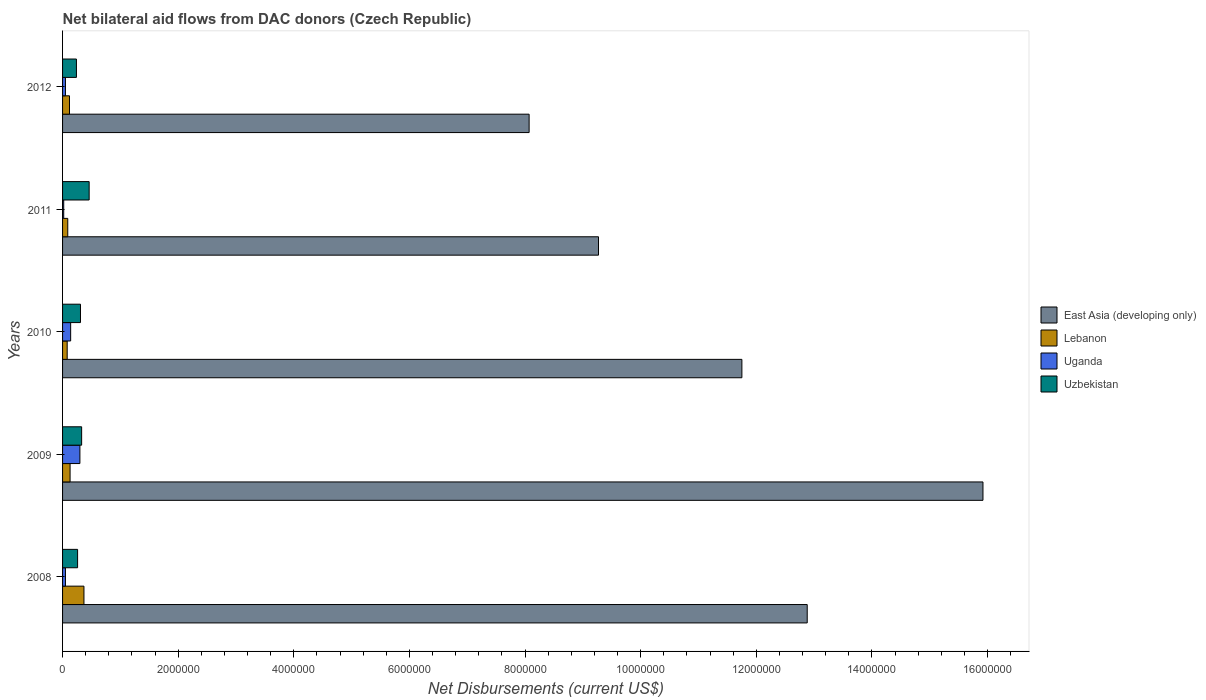Are the number of bars per tick equal to the number of legend labels?
Offer a terse response. Yes. How many bars are there on the 2nd tick from the top?
Your answer should be compact. 4. How many bars are there on the 3rd tick from the bottom?
Give a very brief answer. 4. In how many cases, is the number of bars for a given year not equal to the number of legend labels?
Your answer should be compact. 0. What is the net bilateral aid flows in Lebanon in 2009?
Make the answer very short. 1.30e+05. Across all years, what is the maximum net bilateral aid flows in Uganda?
Offer a very short reply. 3.00e+05. Across all years, what is the minimum net bilateral aid flows in Uzbekistan?
Provide a short and direct response. 2.40e+05. What is the total net bilateral aid flows in Lebanon in the graph?
Offer a very short reply. 7.90e+05. What is the difference between the net bilateral aid flows in Uzbekistan in 2008 and that in 2011?
Give a very brief answer. -2.00e+05. What is the difference between the net bilateral aid flows in Uzbekistan in 2010 and the net bilateral aid flows in East Asia (developing only) in 2012?
Your response must be concise. -7.76e+06. What is the average net bilateral aid flows in Uganda per year?
Provide a short and direct response. 1.12e+05. In the year 2010, what is the difference between the net bilateral aid flows in Uzbekistan and net bilateral aid flows in Uganda?
Keep it short and to the point. 1.70e+05. What is the ratio of the net bilateral aid flows in Lebanon in 2011 to that in 2012?
Keep it short and to the point. 0.75. Is the net bilateral aid flows in East Asia (developing only) in 2009 less than that in 2011?
Your response must be concise. No. What is the difference between the highest and the lowest net bilateral aid flows in Lebanon?
Provide a short and direct response. 2.90e+05. In how many years, is the net bilateral aid flows in Lebanon greater than the average net bilateral aid flows in Lebanon taken over all years?
Your answer should be compact. 1. Is the sum of the net bilateral aid flows in East Asia (developing only) in 2010 and 2011 greater than the maximum net bilateral aid flows in Lebanon across all years?
Your answer should be compact. Yes. What does the 1st bar from the top in 2010 represents?
Your response must be concise. Uzbekistan. What does the 4th bar from the bottom in 2012 represents?
Keep it short and to the point. Uzbekistan. Is it the case that in every year, the sum of the net bilateral aid flows in Uzbekistan and net bilateral aid flows in East Asia (developing only) is greater than the net bilateral aid flows in Uganda?
Offer a very short reply. Yes. How many bars are there?
Your response must be concise. 20. What is the title of the graph?
Give a very brief answer. Net bilateral aid flows from DAC donors (Czech Republic). Does "Chad" appear as one of the legend labels in the graph?
Keep it short and to the point. No. What is the label or title of the X-axis?
Make the answer very short. Net Disbursements (current US$). What is the label or title of the Y-axis?
Give a very brief answer. Years. What is the Net Disbursements (current US$) in East Asia (developing only) in 2008?
Offer a terse response. 1.29e+07. What is the Net Disbursements (current US$) in Uzbekistan in 2008?
Give a very brief answer. 2.60e+05. What is the Net Disbursements (current US$) of East Asia (developing only) in 2009?
Keep it short and to the point. 1.59e+07. What is the Net Disbursements (current US$) of Lebanon in 2009?
Your response must be concise. 1.30e+05. What is the Net Disbursements (current US$) of Uzbekistan in 2009?
Your answer should be compact. 3.30e+05. What is the Net Disbursements (current US$) of East Asia (developing only) in 2010?
Make the answer very short. 1.18e+07. What is the Net Disbursements (current US$) of Lebanon in 2010?
Your response must be concise. 8.00e+04. What is the Net Disbursements (current US$) in Uganda in 2010?
Your answer should be very brief. 1.40e+05. What is the Net Disbursements (current US$) of Uzbekistan in 2010?
Provide a short and direct response. 3.10e+05. What is the Net Disbursements (current US$) of East Asia (developing only) in 2011?
Offer a terse response. 9.27e+06. What is the Net Disbursements (current US$) in Uganda in 2011?
Your answer should be compact. 2.00e+04. What is the Net Disbursements (current US$) of Uzbekistan in 2011?
Offer a very short reply. 4.60e+05. What is the Net Disbursements (current US$) of East Asia (developing only) in 2012?
Ensure brevity in your answer.  8.07e+06. What is the Net Disbursements (current US$) of Lebanon in 2012?
Ensure brevity in your answer.  1.20e+05. What is the Net Disbursements (current US$) of Uganda in 2012?
Provide a short and direct response. 5.00e+04. Across all years, what is the maximum Net Disbursements (current US$) of East Asia (developing only)?
Give a very brief answer. 1.59e+07. Across all years, what is the maximum Net Disbursements (current US$) of Lebanon?
Provide a succinct answer. 3.70e+05. Across all years, what is the maximum Net Disbursements (current US$) of Uzbekistan?
Your answer should be compact. 4.60e+05. Across all years, what is the minimum Net Disbursements (current US$) of East Asia (developing only)?
Provide a short and direct response. 8.07e+06. Across all years, what is the minimum Net Disbursements (current US$) of Uganda?
Make the answer very short. 2.00e+04. Across all years, what is the minimum Net Disbursements (current US$) of Uzbekistan?
Keep it short and to the point. 2.40e+05. What is the total Net Disbursements (current US$) of East Asia (developing only) in the graph?
Your response must be concise. 5.79e+07. What is the total Net Disbursements (current US$) of Lebanon in the graph?
Offer a very short reply. 7.90e+05. What is the total Net Disbursements (current US$) in Uganda in the graph?
Provide a short and direct response. 5.60e+05. What is the total Net Disbursements (current US$) of Uzbekistan in the graph?
Offer a very short reply. 1.60e+06. What is the difference between the Net Disbursements (current US$) of East Asia (developing only) in 2008 and that in 2009?
Provide a succinct answer. -3.04e+06. What is the difference between the Net Disbursements (current US$) of Uganda in 2008 and that in 2009?
Keep it short and to the point. -2.50e+05. What is the difference between the Net Disbursements (current US$) of East Asia (developing only) in 2008 and that in 2010?
Offer a very short reply. 1.13e+06. What is the difference between the Net Disbursements (current US$) in East Asia (developing only) in 2008 and that in 2011?
Offer a very short reply. 3.61e+06. What is the difference between the Net Disbursements (current US$) of East Asia (developing only) in 2008 and that in 2012?
Offer a terse response. 4.81e+06. What is the difference between the Net Disbursements (current US$) in Lebanon in 2008 and that in 2012?
Offer a terse response. 2.50e+05. What is the difference between the Net Disbursements (current US$) in Uzbekistan in 2008 and that in 2012?
Give a very brief answer. 2.00e+04. What is the difference between the Net Disbursements (current US$) of East Asia (developing only) in 2009 and that in 2010?
Your answer should be very brief. 4.17e+06. What is the difference between the Net Disbursements (current US$) of Lebanon in 2009 and that in 2010?
Offer a very short reply. 5.00e+04. What is the difference between the Net Disbursements (current US$) of Uganda in 2009 and that in 2010?
Provide a succinct answer. 1.60e+05. What is the difference between the Net Disbursements (current US$) in East Asia (developing only) in 2009 and that in 2011?
Your response must be concise. 6.65e+06. What is the difference between the Net Disbursements (current US$) of Uzbekistan in 2009 and that in 2011?
Keep it short and to the point. -1.30e+05. What is the difference between the Net Disbursements (current US$) of East Asia (developing only) in 2009 and that in 2012?
Ensure brevity in your answer.  7.85e+06. What is the difference between the Net Disbursements (current US$) in Uganda in 2009 and that in 2012?
Keep it short and to the point. 2.50e+05. What is the difference between the Net Disbursements (current US$) of East Asia (developing only) in 2010 and that in 2011?
Provide a succinct answer. 2.48e+06. What is the difference between the Net Disbursements (current US$) of Uganda in 2010 and that in 2011?
Your answer should be very brief. 1.20e+05. What is the difference between the Net Disbursements (current US$) of Uzbekistan in 2010 and that in 2011?
Make the answer very short. -1.50e+05. What is the difference between the Net Disbursements (current US$) of East Asia (developing only) in 2010 and that in 2012?
Make the answer very short. 3.68e+06. What is the difference between the Net Disbursements (current US$) of East Asia (developing only) in 2011 and that in 2012?
Provide a short and direct response. 1.20e+06. What is the difference between the Net Disbursements (current US$) of Lebanon in 2011 and that in 2012?
Provide a succinct answer. -3.00e+04. What is the difference between the Net Disbursements (current US$) of Uzbekistan in 2011 and that in 2012?
Keep it short and to the point. 2.20e+05. What is the difference between the Net Disbursements (current US$) in East Asia (developing only) in 2008 and the Net Disbursements (current US$) in Lebanon in 2009?
Your response must be concise. 1.28e+07. What is the difference between the Net Disbursements (current US$) in East Asia (developing only) in 2008 and the Net Disbursements (current US$) in Uganda in 2009?
Provide a succinct answer. 1.26e+07. What is the difference between the Net Disbursements (current US$) of East Asia (developing only) in 2008 and the Net Disbursements (current US$) of Uzbekistan in 2009?
Offer a very short reply. 1.26e+07. What is the difference between the Net Disbursements (current US$) of Lebanon in 2008 and the Net Disbursements (current US$) of Uganda in 2009?
Your response must be concise. 7.00e+04. What is the difference between the Net Disbursements (current US$) in Uganda in 2008 and the Net Disbursements (current US$) in Uzbekistan in 2009?
Make the answer very short. -2.80e+05. What is the difference between the Net Disbursements (current US$) in East Asia (developing only) in 2008 and the Net Disbursements (current US$) in Lebanon in 2010?
Make the answer very short. 1.28e+07. What is the difference between the Net Disbursements (current US$) in East Asia (developing only) in 2008 and the Net Disbursements (current US$) in Uganda in 2010?
Your answer should be compact. 1.27e+07. What is the difference between the Net Disbursements (current US$) of East Asia (developing only) in 2008 and the Net Disbursements (current US$) of Uzbekistan in 2010?
Give a very brief answer. 1.26e+07. What is the difference between the Net Disbursements (current US$) of Lebanon in 2008 and the Net Disbursements (current US$) of Uzbekistan in 2010?
Offer a very short reply. 6.00e+04. What is the difference between the Net Disbursements (current US$) in Uganda in 2008 and the Net Disbursements (current US$) in Uzbekistan in 2010?
Your answer should be compact. -2.60e+05. What is the difference between the Net Disbursements (current US$) of East Asia (developing only) in 2008 and the Net Disbursements (current US$) of Lebanon in 2011?
Provide a succinct answer. 1.28e+07. What is the difference between the Net Disbursements (current US$) of East Asia (developing only) in 2008 and the Net Disbursements (current US$) of Uganda in 2011?
Offer a terse response. 1.29e+07. What is the difference between the Net Disbursements (current US$) in East Asia (developing only) in 2008 and the Net Disbursements (current US$) in Uzbekistan in 2011?
Make the answer very short. 1.24e+07. What is the difference between the Net Disbursements (current US$) of Lebanon in 2008 and the Net Disbursements (current US$) of Uzbekistan in 2011?
Your answer should be very brief. -9.00e+04. What is the difference between the Net Disbursements (current US$) of Uganda in 2008 and the Net Disbursements (current US$) of Uzbekistan in 2011?
Make the answer very short. -4.10e+05. What is the difference between the Net Disbursements (current US$) of East Asia (developing only) in 2008 and the Net Disbursements (current US$) of Lebanon in 2012?
Make the answer very short. 1.28e+07. What is the difference between the Net Disbursements (current US$) in East Asia (developing only) in 2008 and the Net Disbursements (current US$) in Uganda in 2012?
Your answer should be compact. 1.28e+07. What is the difference between the Net Disbursements (current US$) in East Asia (developing only) in 2008 and the Net Disbursements (current US$) in Uzbekistan in 2012?
Offer a terse response. 1.26e+07. What is the difference between the Net Disbursements (current US$) in Lebanon in 2008 and the Net Disbursements (current US$) in Uganda in 2012?
Your answer should be very brief. 3.20e+05. What is the difference between the Net Disbursements (current US$) of Uganda in 2008 and the Net Disbursements (current US$) of Uzbekistan in 2012?
Give a very brief answer. -1.90e+05. What is the difference between the Net Disbursements (current US$) in East Asia (developing only) in 2009 and the Net Disbursements (current US$) in Lebanon in 2010?
Your response must be concise. 1.58e+07. What is the difference between the Net Disbursements (current US$) in East Asia (developing only) in 2009 and the Net Disbursements (current US$) in Uganda in 2010?
Make the answer very short. 1.58e+07. What is the difference between the Net Disbursements (current US$) of East Asia (developing only) in 2009 and the Net Disbursements (current US$) of Uzbekistan in 2010?
Offer a very short reply. 1.56e+07. What is the difference between the Net Disbursements (current US$) in Lebanon in 2009 and the Net Disbursements (current US$) in Uganda in 2010?
Your response must be concise. -10000. What is the difference between the Net Disbursements (current US$) of Uganda in 2009 and the Net Disbursements (current US$) of Uzbekistan in 2010?
Your answer should be very brief. -10000. What is the difference between the Net Disbursements (current US$) of East Asia (developing only) in 2009 and the Net Disbursements (current US$) of Lebanon in 2011?
Your answer should be very brief. 1.58e+07. What is the difference between the Net Disbursements (current US$) of East Asia (developing only) in 2009 and the Net Disbursements (current US$) of Uganda in 2011?
Offer a terse response. 1.59e+07. What is the difference between the Net Disbursements (current US$) in East Asia (developing only) in 2009 and the Net Disbursements (current US$) in Uzbekistan in 2011?
Make the answer very short. 1.55e+07. What is the difference between the Net Disbursements (current US$) in Lebanon in 2009 and the Net Disbursements (current US$) in Uzbekistan in 2011?
Provide a short and direct response. -3.30e+05. What is the difference between the Net Disbursements (current US$) of Uganda in 2009 and the Net Disbursements (current US$) of Uzbekistan in 2011?
Your response must be concise. -1.60e+05. What is the difference between the Net Disbursements (current US$) of East Asia (developing only) in 2009 and the Net Disbursements (current US$) of Lebanon in 2012?
Your response must be concise. 1.58e+07. What is the difference between the Net Disbursements (current US$) in East Asia (developing only) in 2009 and the Net Disbursements (current US$) in Uganda in 2012?
Your answer should be compact. 1.59e+07. What is the difference between the Net Disbursements (current US$) in East Asia (developing only) in 2009 and the Net Disbursements (current US$) in Uzbekistan in 2012?
Your answer should be compact. 1.57e+07. What is the difference between the Net Disbursements (current US$) in East Asia (developing only) in 2010 and the Net Disbursements (current US$) in Lebanon in 2011?
Ensure brevity in your answer.  1.17e+07. What is the difference between the Net Disbursements (current US$) in East Asia (developing only) in 2010 and the Net Disbursements (current US$) in Uganda in 2011?
Your response must be concise. 1.17e+07. What is the difference between the Net Disbursements (current US$) in East Asia (developing only) in 2010 and the Net Disbursements (current US$) in Uzbekistan in 2011?
Your answer should be compact. 1.13e+07. What is the difference between the Net Disbursements (current US$) of Lebanon in 2010 and the Net Disbursements (current US$) of Uzbekistan in 2011?
Ensure brevity in your answer.  -3.80e+05. What is the difference between the Net Disbursements (current US$) in Uganda in 2010 and the Net Disbursements (current US$) in Uzbekistan in 2011?
Provide a short and direct response. -3.20e+05. What is the difference between the Net Disbursements (current US$) of East Asia (developing only) in 2010 and the Net Disbursements (current US$) of Lebanon in 2012?
Your answer should be compact. 1.16e+07. What is the difference between the Net Disbursements (current US$) in East Asia (developing only) in 2010 and the Net Disbursements (current US$) in Uganda in 2012?
Give a very brief answer. 1.17e+07. What is the difference between the Net Disbursements (current US$) of East Asia (developing only) in 2010 and the Net Disbursements (current US$) of Uzbekistan in 2012?
Keep it short and to the point. 1.15e+07. What is the difference between the Net Disbursements (current US$) in Lebanon in 2010 and the Net Disbursements (current US$) in Uganda in 2012?
Your response must be concise. 3.00e+04. What is the difference between the Net Disbursements (current US$) in Lebanon in 2010 and the Net Disbursements (current US$) in Uzbekistan in 2012?
Provide a short and direct response. -1.60e+05. What is the difference between the Net Disbursements (current US$) in Uganda in 2010 and the Net Disbursements (current US$) in Uzbekistan in 2012?
Your answer should be compact. -1.00e+05. What is the difference between the Net Disbursements (current US$) in East Asia (developing only) in 2011 and the Net Disbursements (current US$) in Lebanon in 2012?
Your answer should be compact. 9.15e+06. What is the difference between the Net Disbursements (current US$) of East Asia (developing only) in 2011 and the Net Disbursements (current US$) of Uganda in 2012?
Give a very brief answer. 9.22e+06. What is the difference between the Net Disbursements (current US$) of East Asia (developing only) in 2011 and the Net Disbursements (current US$) of Uzbekistan in 2012?
Give a very brief answer. 9.03e+06. What is the difference between the Net Disbursements (current US$) in Lebanon in 2011 and the Net Disbursements (current US$) in Uganda in 2012?
Your answer should be very brief. 4.00e+04. What is the difference between the Net Disbursements (current US$) in Lebanon in 2011 and the Net Disbursements (current US$) in Uzbekistan in 2012?
Your answer should be very brief. -1.50e+05. What is the difference between the Net Disbursements (current US$) of Uganda in 2011 and the Net Disbursements (current US$) of Uzbekistan in 2012?
Ensure brevity in your answer.  -2.20e+05. What is the average Net Disbursements (current US$) of East Asia (developing only) per year?
Your answer should be very brief. 1.16e+07. What is the average Net Disbursements (current US$) of Lebanon per year?
Provide a succinct answer. 1.58e+05. What is the average Net Disbursements (current US$) of Uganda per year?
Offer a terse response. 1.12e+05. In the year 2008, what is the difference between the Net Disbursements (current US$) in East Asia (developing only) and Net Disbursements (current US$) in Lebanon?
Your answer should be very brief. 1.25e+07. In the year 2008, what is the difference between the Net Disbursements (current US$) of East Asia (developing only) and Net Disbursements (current US$) of Uganda?
Provide a succinct answer. 1.28e+07. In the year 2008, what is the difference between the Net Disbursements (current US$) in East Asia (developing only) and Net Disbursements (current US$) in Uzbekistan?
Make the answer very short. 1.26e+07. In the year 2008, what is the difference between the Net Disbursements (current US$) in Lebanon and Net Disbursements (current US$) in Uzbekistan?
Ensure brevity in your answer.  1.10e+05. In the year 2009, what is the difference between the Net Disbursements (current US$) of East Asia (developing only) and Net Disbursements (current US$) of Lebanon?
Give a very brief answer. 1.58e+07. In the year 2009, what is the difference between the Net Disbursements (current US$) in East Asia (developing only) and Net Disbursements (current US$) in Uganda?
Make the answer very short. 1.56e+07. In the year 2009, what is the difference between the Net Disbursements (current US$) in East Asia (developing only) and Net Disbursements (current US$) in Uzbekistan?
Your answer should be compact. 1.56e+07. In the year 2009, what is the difference between the Net Disbursements (current US$) of Lebanon and Net Disbursements (current US$) of Uzbekistan?
Give a very brief answer. -2.00e+05. In the year 2009, what is the difference between the Net Disbursements (current US$) of Uganda and Net Disbursements (current US$) of Uzbekistan?
Offer a terse response. -3.00e+04. In the year 2010, what is the difference between the Net Disbursements (current US$) in East Asia (developing only) and Net Disbursements (current US$) in Lebanon?
Provide a succinct answer. 1.17e+07. In the year 2010, what is the difference between the Net Disbursements (current US$) of East Asia (developing only) and Net Disbursements (current US$) of Uganda?
Provide a short and direct response. 1.16e+07. In the year 2010, what is the difference between the Net Disbursements (current US$) in East Asia (developing only) and Net Disbursements (current US$) in Uzbekistan?
Ensure brevity in your answer.  1.14e+07. In the year 2011, what is the difference between the Net Disbursements (current US$) of East Asia (developing only) and Net Disbursements (current US$) of Lebanon?
Offer a terse response. 9.18e+06. In the year 2011, what is the difference between the Net Disbursements (current US$) of East Asia (developing only) and Net Disbursements (current US$) of Uganda?
Your response must be concise. 9.25e+06. In the year 2011, what is the difference between the Net Disbursements (current US$) in East Asia (developing only) and Net Disbursements (current US$) in Uzbekistan?
Keep it short and to the point. 8.81e+06. In the year 2011, what is the difference between the Net Disbursements (current US$) in Lebanon and Net Disbursements (current US$) in Uganda?
Keep it short and to the point. 7.00e+04. In the year 2011, what is the difference between the Net Disbursements (current US$) of Lebanon and Net Disbursements (current US$) of Uzbekistan?
Your answer should be compact. -3.70e+05. In the year 2011, what is the difference between the Net Disbursements (current US$) in Uganda and Net Disbursements (current US$) in Uzbekistan?
Your answer should be very brief. -4.40e+05. In the year 2012, what is the difference between the Net Disbursements (current US$) of East Asia (developing only) and Net Disbursements (current US$) of Lebanon?
Ensure brevity in your answer.  7.95e+06. In the year 2012, what is the difference between the Net Disbursements (current US$) in East Asia (developing only) and Net Disbursements (current US$) in Uganda?
Keep it short and to the point. 8.02e+06. In the year 2012, what is the difference between the Net Disbursements (current US$) of East Asia (developing only) and Net Disbursements (current US$) of Uzbekistan?
Your response must be concise. 7.83e+06. In the year 2012, what is the difference between the Net Disbursements (current US$) in Lebanon and Net Disbursements (current US$) in Uganda?
Offer a very short reply. 7.00e+04. In the year 2012, what is the difference between the Net Disbursements (current US$) in Lebanon and Net Disbursements (current US$) in Uzbekistan?
Your answer should be very brief. -1.20e+05. In the year 2012, what is the difference between the Net Disbursements (current US$) in Uganda and Net Disbursements (current US$) in Uzbekistan?
Your response must be concise. -1.90e+05. What is the ratio of the Net Disbursements (current US$) of East Asia (developing only) in 2008 to that in 2009?
Provide a succinct answer. 0.81. What is the ratio of the Net Disbursements (current US$) in Lebanon in 2008 to that in 2009?
Give a very brief answer. 2.85. What is the ratio of the Net Disbursements (current US$) in Uzbekistan in 2008 to that in 2009?
Provide a short and direct response. 0.79. What is the ratio of the Net Disbursements (current US$) of East Asia (developing only) in 2008 to that in 2010?
Make the answer very short. 1.1. What is the ratio of the Net Disbursements (current US$) of Lebanon in 2008 to that in 2010?
Your answer should be compact. 4.62. What is the ratio of the Net Disbursements (current US$) in Uganda in 2008 to that in 2010?
Ensure brevity in your answer.  0.36. What is the ratio of the Net Disbursements (current US$) of Uzbekistan in 2008 to that in 2010?
Provide a succinct answer. 0.84. What is the ratio of the Net Disbursements (current US$) in East Asia (developing only) in 2008 to that in 2011?
Your answer should be very brief. 1.39. What is the ratio of the Net Disbursements (current US$) in Lebanon in 2008 to that in 2011?
Give a very brief answer. 4.11. What is the ratio of the Net Disbursements (current US$) of Uzbekistan in 2008 to that in 2011?
Offer a terse response. 0.57. What is the ratio of the Net Disbursements (current US$) of East Asia (developing only) in 2008 to that in 2012?
Ensure brevity in your answer.  1.6. What is the ratio of the Net Disbursements (current US$) in Lebanon in 2008 to that in 2012?
Your response must be concise. 3.08. What is the ratio of the Net Disbursements (current US$) of Uganda in 2008 to that in 2012?
Ensure brevity in your answer.  1. What is the ratio of the Net Disbursements (current US$) of Uzbekistan in 2008 to that in 2012?
Your response must be concise. 1.08. What is the ratio of the Net Disbursements (current US$) in East Asia (developing only) in 2009 to that in 2010?
Make the answer very short. 1.35. What is the ratio of the Net Disbursements (current US$) in Lebanon in 2009 to that in 2010?
Your answer should be compact. 1.62. What is the ratio of the Net Disbursements (current US$) in Uganda in 2009 to that in 2010?
Provide a succinct answer. 2.14. What is the ratio of the Net Disbursements (current US$) of Uzbekistan in 2009 to that in 2010?
Provide a short and direct response. 1.06. What is the ratio of the Net Disbursements (current US$) of East Asia (developing only) in 2009 to that in 2011?
Provide a succinct answer. 1.72. What is the ratio of the Net Disbursements (current US$) in Lebanon in 2009 to that in 2011?
Keep it short and to the point. 1.44. What is the ratio of the Net Disbursements (current US$) in Uganda in 2009 to that in 2011?
Provide a succinct answer. 15. What is the ratio of the Net Disbursements (current US$) in Uzbekistan in 2009 to that in 2011?
Your answer should be very brief. 0.72. What is the ratio of the Net Disbursements (current US$) in East Asia (developing only) in 2009 to that in 2012?
Offer a very short reply. 1.97. What is the ratio of the Net Disbursements (current US$) in Lebanon in 2009 to that in 2012?
Ensure brevity in your answer.  1.08. What is the ratio of the Net Disbursements (current US$) of Uzbekistan in 2009 to that in 2012?
Give a very brief answer. 1.38. What is the ratio of the Net Disbursements (current US$) in East Asia (developing only) in 2010 to that in 2011?
Offer a very short reply. 1.27. What is the ratio of the Net Disbursements (current US$) of Lebanon in 2010 to that in 2011?
Provide a succinct answer. 0.89. What is the ratio of the Net Disbursements (current US$) in Uzbekistan in 2010 to that in 2011?
Ensure brevity in your answer.  0.67. What is the ratio of the Net Disbursements (current US$) of East Asia (developing only) in 2010 to that in 2012?
Ensure brevity in your answer.  1.46. What is the ratio of the Net Disbursements (current US$) in Uganda in 2010 to that in 2012?
Your answer should be very brief. 2.8. What is the ratio of the Net Disbursements (current US$) of Uzbekistan in 2010 to that in 2012?
Offer a terse response. 1.29. What is the ratio of the Net Disbursements (current US$) of East Asia (developing only) in 2011 to that in 2012?
Offer a very short reply. 1.15. What is the ratio of the Net Disbursements (current US$) in Lebanon in 2011 to that in 2012?
Provide a succinct answer. 0.75. What is the ratio of the Net Disbursements (current US$) in Uzbekistan in 2011 to that in 2012?
Keep it short and to the point. 1.92. What is the difference between the highest and the second highest Net Disbursements (current US$) of East Asia (developing only)?
Keep it short and to the point. 3.04e+06. What is the difference between the highest and the second highest Net Disbursements (current US$) of Lebanon?
Give a very brief answer. 2.40e+05. What is the difference between the highest and the second highest Net Disbursements (current US$) of Uganda?
Offer a very short reply. 1.60e+05. What is the difference between the highest and the second highest Net Disbursements (current US$) in Uzbekistan?
Your answer should be very brief. 1.30e+05. What is the difference between the highest and the lowest Net Disbursements (current US$) in East Asia (developing only)?
Keep it short and to the point. 7.85e+06. What is the difference between the highest and the lowest Net Disbursements (current US$) of Lebanon?
Your answer should be very brief. 2.90e+05. What is the difference between the highest and the lowest Net Disbursements (current US$) of Uganda?
Make the answer very short. 2.80e+05. 